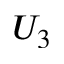Convert formula to latex. <formula><loc_0><loc_0><loc_500><loc_500>U _ { 3 }</formula> 